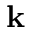Convert formula to latex. <formula><loc_0><loc_0><loc_500><loc_500>k</formula> 